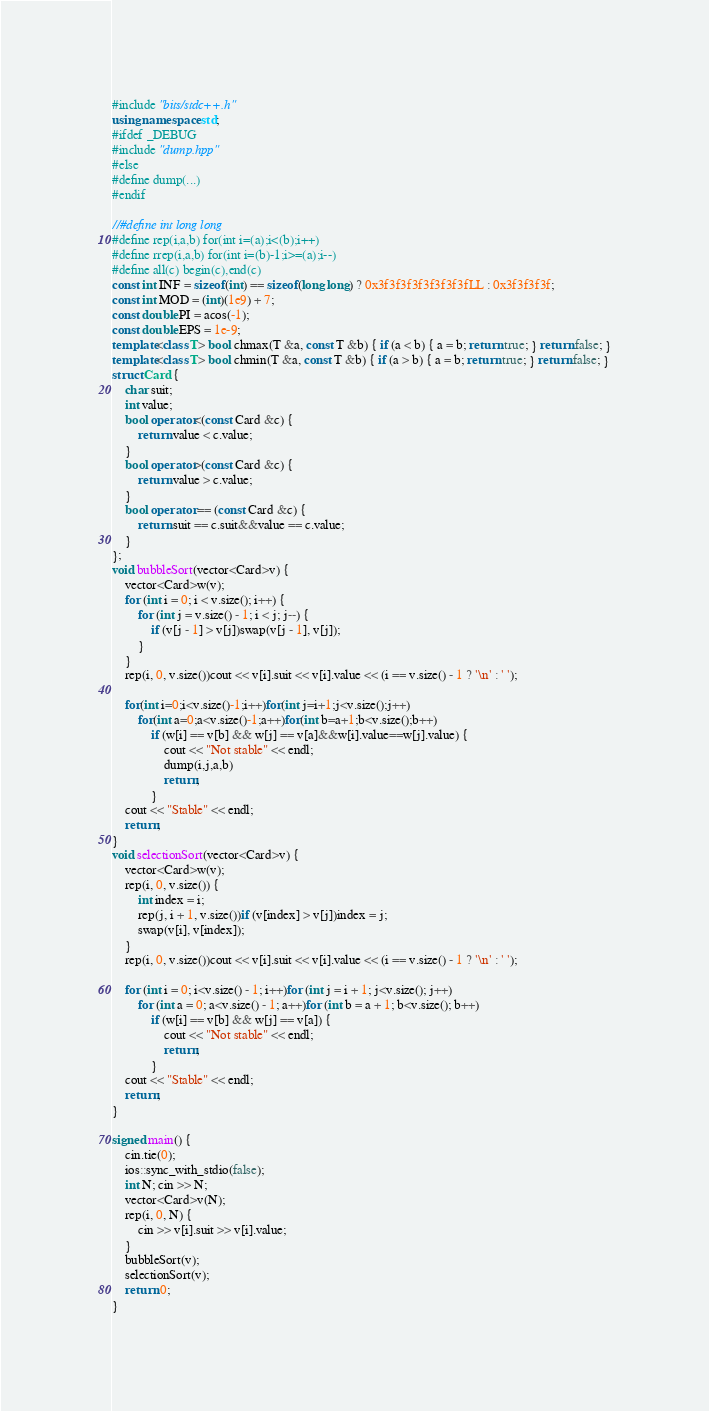Convert code to text. <code><loc_0><loc_0><loc_500><loc_500><_C++_>#include "bits/stdc++.h"
using namespace std;
#ifdef _DEBUG
#include "dump.hpp"
#else
#define dump(...)
#endif

//#define int long long
#define rep(i,a,b) for(int i=(a);i<(b);i++)
#define rrep(i,a,b) for(int i=(b)-1;i>=(a);i--)
#define all(c) begin(c),end(c)
const int INF = sizeof(int) == sizeof(long long) ? 0x3f3f3f3f3f3f3f3fLL : 0x3f3f3f3f;
const int MOD = (int)(1e9) + 7;
const double PI = acos(-1);
const double EPS = 1e-9;
template<class T> bool chmax(T &a, const T &b) { if (a < b) { a = b; return true; } return false; }
template<class T> bool chmin(T &a, const T &b) { if (a > b) { a = b; return true; } return false; }
struct Card {
	char suit;
	int value;
	bool operator<(const Card &c) {
		return value < c.value;
	}
	bool operator>(const Card &c) {
		return value > c.value;
	}
	bool operator == (const Card &c) {
		return suit == c.suit&&value == c.value;
	}
};
void bubbleSort(vector<Card>v) {
	vector<Card>w(v);
	for (int i = 0; i < v.size(); i++) {
		for (int j = v.size() - 1; i < j; j--) {
			if (v[j - 1] > v[j])swap(v[j - 1], v[j]);
		}
	}
	rep(i, 0, v.size())cout << v[i].suit << v[i].value << (i == v.size() - 1 ? '\n' : ' ');

	for(int i=0;i<v.size()-1;i++)for(int j=i+1;j<v.size();j++)
		for(int a=0;a<v.size()-1;a++)for(int b=a+1;b<v.size();b++)
			if (w[i] == v[b] && w[j] == v[a]&&w[i].value==w[j].value) {
				cout << "Not stable" << endl;
				dump(i,j,a,b)	
				return;
			}
	cout << "Stable" << endl;
	return;
}
void selectionSort(vector<Card>v) {
	vector<Card>w(v);
	rep(i, 0, v.size()) {
		int index = i;
		rep(j, i + 1, v.size())if (v[index] > v[j])index = j;
		swap(v[i], v[index]);
	}
	rep(i, 0, v.size())cout << v[i].suit << v[i].value << (i == v.size() - 1 ? '\n' : ' ');

	for (int i = 0; i<v.size() - 1; i++)for (int j = i + 1; j<v.size(); j++)
		for (int a = 0; a<v.size() - 1; a++)for (int b = a + 1; b<v.size(); b++)
			if (w[i] == v[b] && w[j] == v[a]) {
				cout << "Not stable" << endl;
				return;
			}
	cout << "Stable" << endl;
	return;
}

signed main() {
	cin.tie(0);
	ios::sync_with_stdio(false);
	int N; cin >> N;
	vector<Card>v(N);
	rep(i, 0, N) {
		cin >> v[i].suit >> v[i].value;
	}
	bubbleSort(v);
	selectionSort(v);
	return 0;
}</code> 